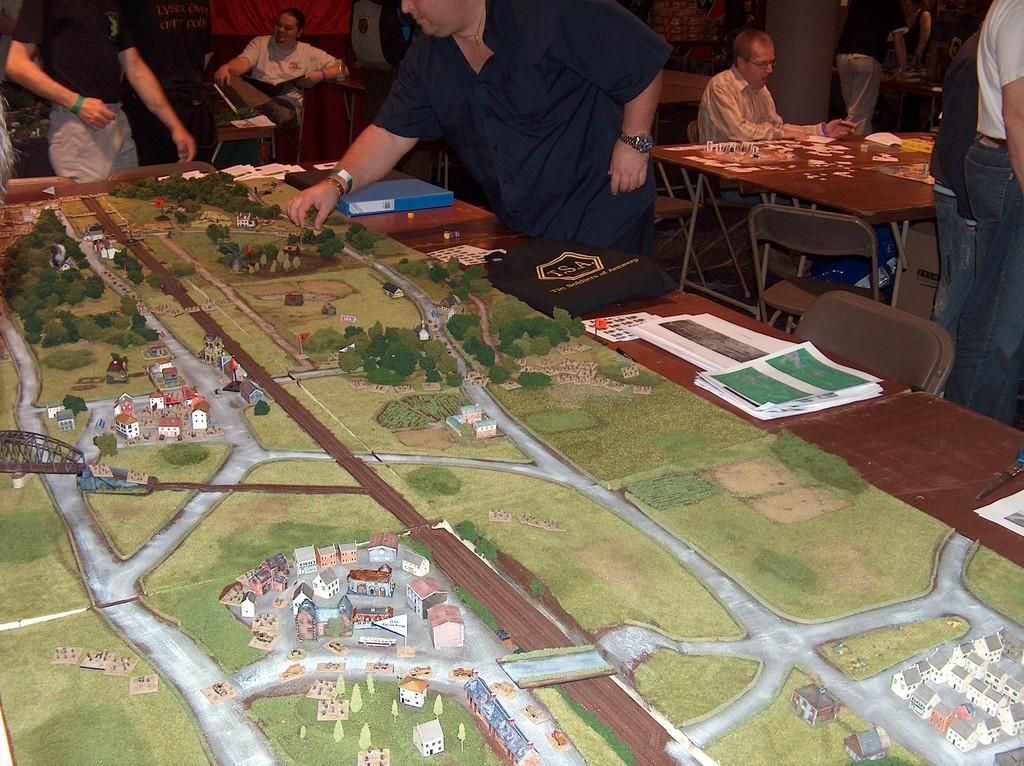How would you summarize this image in a sentence or two? In this picture we can see a group of people where some are standing and some are sitting on chairs and in front of them on table we have papers, bag, file, stickers, some plan and in background we can see curtain, wall, chairs, box. 